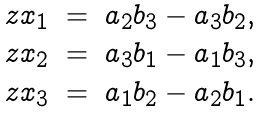<formula> <loc_0><loc_0><loc_500><loc_500>\begin{matrix} z x _ { 1 } & = & a _ { 2 } b _ { 3 } - a _ { 3 } b _ { 2 } , \\ z x _ { 2 } & = & a _ { 3 } b _ { 1 } - a _ { 1 } b _ { 3 } , \\ z x _ { 3 } & = & a _ { 1 } b _ { 2 } - a _ { 2 } b _ { 1 } . \\ \end{matrix}</formula> 